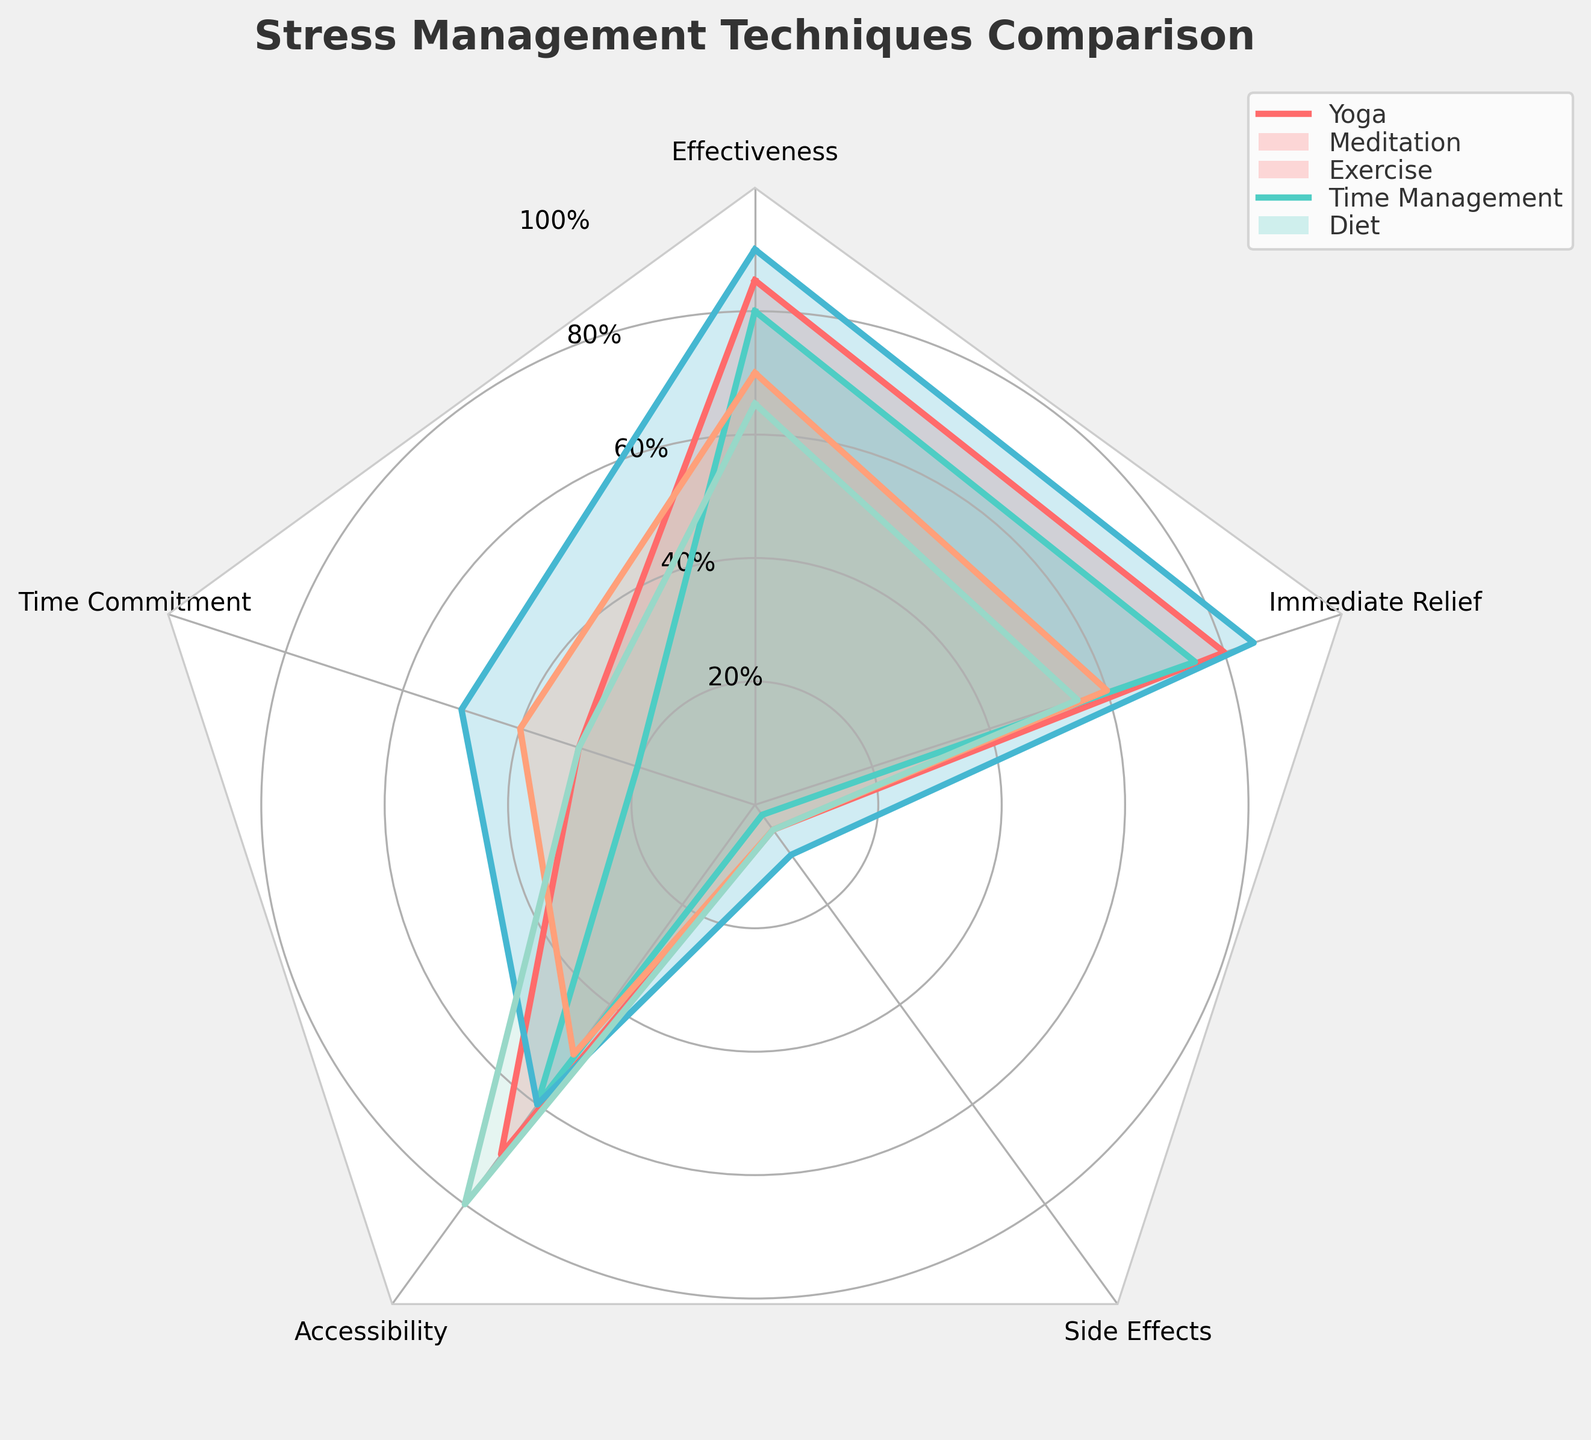What's the title of the figure? The title of the figure is usually found at the top of the chart. In this case, the title reads "Stress Management Techniques Comparison".
Answer: Stress Management Techniques Comparison How many stress management techniques are compared in the radar chart? There are five different colored lines and labels in the legend, each representing a different stress management technique.
Answer: Five Which technique requires the least time commitment? Refer to the "Time Commitment" axis and observe the values for each technique. The shortest bar corresponds to Meditation.
Answer: Meditation What's the highest effectiveness score among all techniques? Look at the "Effectiveness" axis and find the highest point reached. The technique with the highest effectiveness score is Exercise, with a value of 90.
Answer: 90 Between Yoga and Exercise, which technique provides more immediate relief? Compare the values of the "Immediate Relief" axis for both Yoga and Exercise. Yoga has a score of 80, while Exercise has 85. Exercise provides more immediate relief.
Answer: Exercise Which technique has the highest accessibility? Check the "Accessibility" axis and see which technique reaches the farthest. The highest value belongs to Diet.
Answer: Diet What is the average effectiveness of Yoga, Meditation, and Exercise? The effectiveness scores are: Yoga 85, Meditation 80, and Exercise 90. Sum these scores (85+80+90 = 255) and divide by the number of techniques (255/3).
Answer: 85 Which technique has the least side effects? Look at the "Side Effects" axis and find the lowest bar. Meditation has the lowest value (2).
Answer: Meditation Compare Time Management and Diet: which one is easier based on accessibility? Both values are shown on the "Accessibility" axis. Time Management has 50, while Diet has 80. Diet is easier based on accessibility.
Answer: Diet What is the difference in immediate relief between Time Management and Yoga? The immediate relief scores are: Time Management 60, Yoga 80. Subtract these values (80 - 60).
Answer: 20 